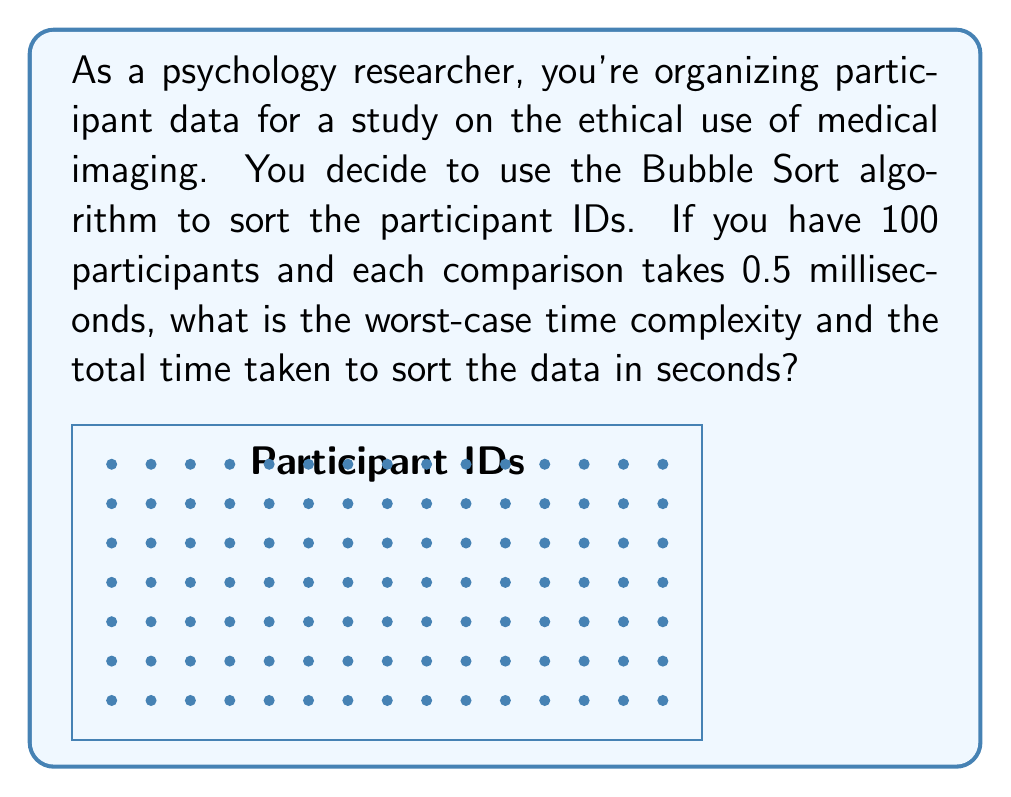Teach me how to tackle this problem. To solve this problem, let's break it down step-by-step:

1. Worst-case time complexity of Bubble Sort:
   The worst-case scenario occurs when the list is in reverse order.
   In this case, for n elements, we need:
   $$(n-1) + (n-2) + ... + 2 + 1 = \frac{n(n-1)}{2}$$ comparisons

2. For n = 100 participants:
   $$\frac{100(100-1)}{2} = \frac{100 \times 99}{2} = 4950$$ comparisons

3. Time taken for each comparison: 0.5 milliseconds = 0.0005 seconds

4. Total time:
   $$4950 \times 0.0005 = 2.475$$ seconds

5. Worst-case time complexity:
   Bubble Sort has a worst-case time complexity of $O(n^2)$

Therefore, the worst-case time complexity is $O(n^2)$, and the total time taken to sort 100 participant IDs is 2.475 seconds.
Answer: $O(n^2)$, 2.475 seconds 